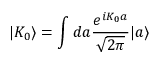Convert formula to latex. <formula><loc_0><loc_0><loc_500><loc_500>| K _ { 0 } \rangle = \int d a \frac { e ^ { i K _ { 0 } a } } { \sqrt { 2 \pi } } | a \rangle</formula> 